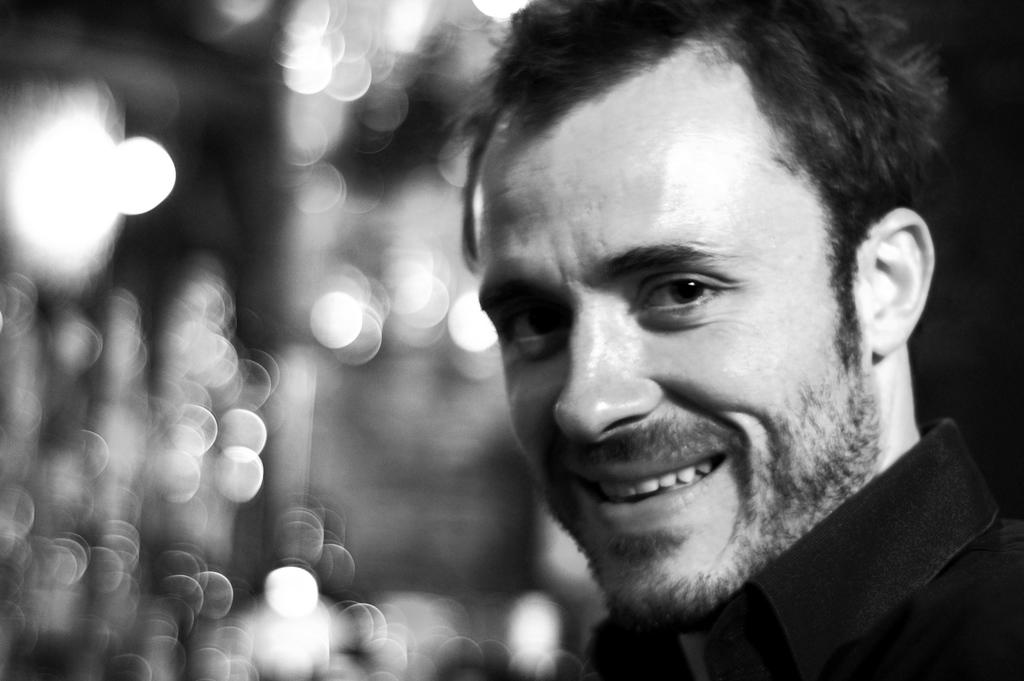What is the color scheme of the image? The image is black and white. Can you describe the person in the image? There is a person in the image. What expression does the person have? The person is smiling. How many friends can be seen in the image? There are no friends visible in the image; only one person is present. What type of rail is the person holding onto in the image? There is no rail present in the image; it is a black and white image of a person smiling. 